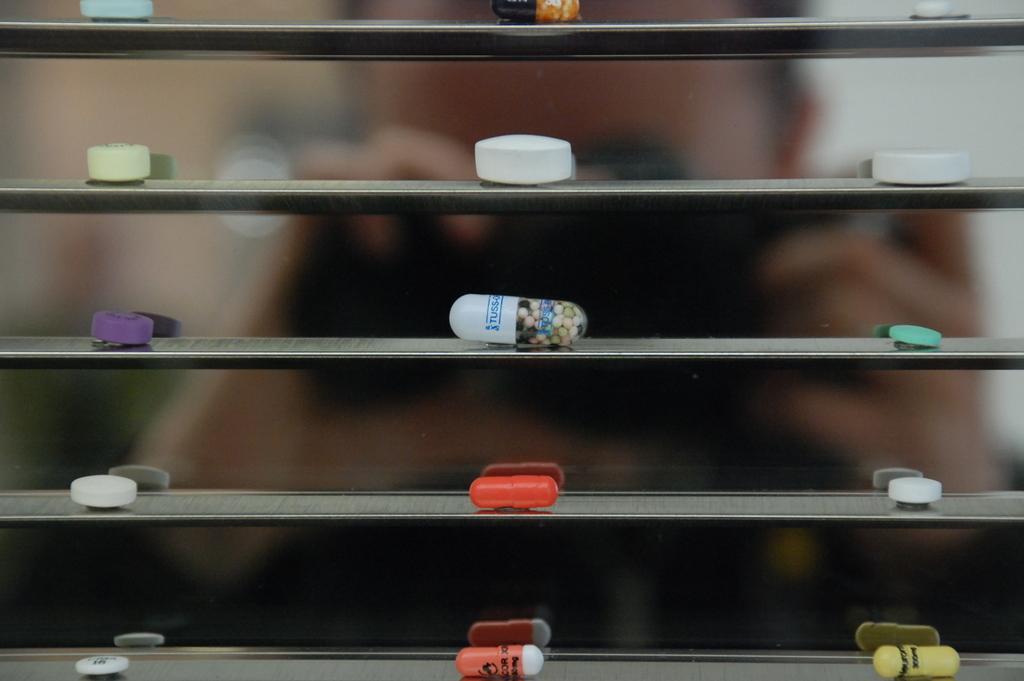In one or two sentences, can you explain what this image depicts? In this image the background is a little blurred and there is a person. In the middle of the image there are a few capsules and tablets on the shelves. 